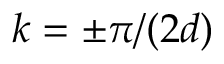<formula> <loc_0><loc_0><loc_500><loc_500>k = \pm \pi / ( 2 d )</formula> 